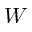<formula> <loc_0><loc_0><loc_500><loc_500>W</formula> 